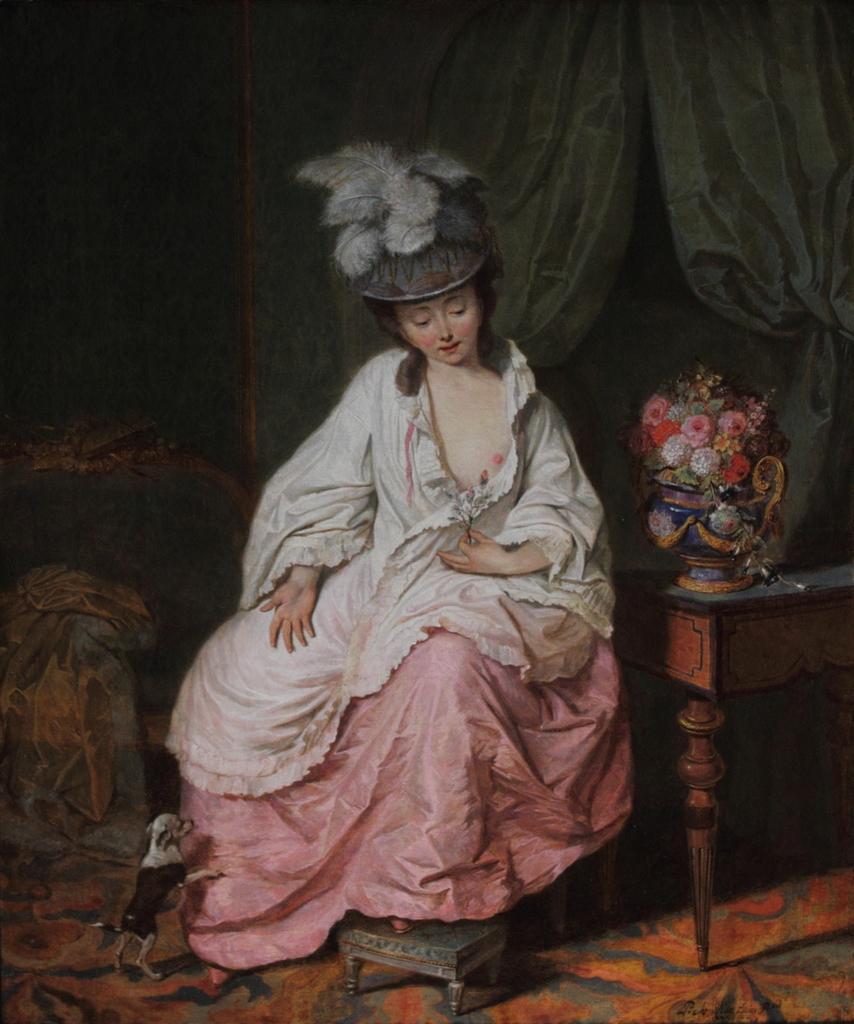Could you give a brief overview of what you see in this image? In the picture we can see a painting of a woman sitting in a white dress and beside her we can see a table with flower vase and some flowers in it and behind her we can see a black curtain. 